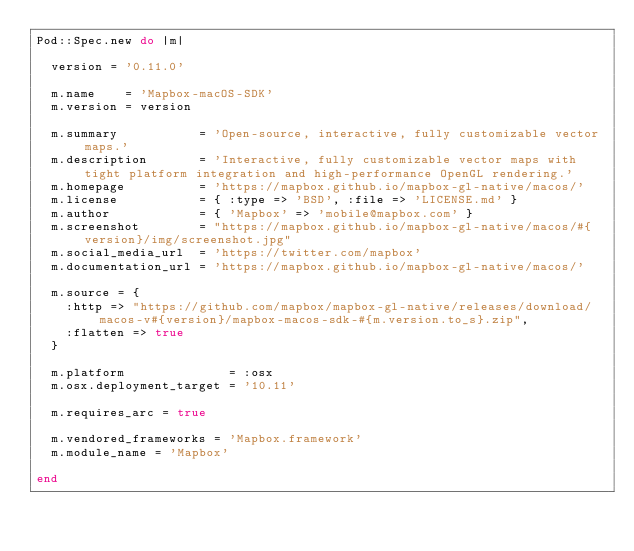<code> <loc_0><loc_0><loc_500><loc_500><_Ruby_>Pod::Spec.new do |m|

  version = '0.11.0'

  m.name    = 'Mapbox-macOS-SDK'
  m.version = version

  m.summary           = 'Open-source, interactive, fully customizable vector maps.'
  m.description       = 'Interactive, fully customizable vector maps with tight platform integration and high-performance OpenGL rendering.'
  m.homepage          = 'https://mapbox.github.io/mapbox-gl-native/macos/'
  m.license           = { :type => 'BSD', :file => 'LICENSE.md' }
  m.author            = { 'Mapbox' => 'mobile@mapbox.com' }
  m.screenshot        = "https://mapbox.github.io/mapbox-gl-native/macos/#{version}/img/screenshot.jpg"
  m.social_media_url  = 'https://twitter.com/mapbox'
  m.documentation_url = 'https://mapbox.github.io/mapbox-gl-native/macos/'

  m.source = {
    :http => "https://github.com/mapbox/mapbox-gl-native/releases/download/macos-v#{version}/mapbox-macos-sdk-#{m.version.to_s}.zip",
    :flatten => true
  }

  m.platform              = :osx
  m.osx.deployment_target = '10.11'

  m.requires_arc = true

  m.vendored_frameworks = 'Mapbox.framework'
  m.module_name = 'Mapbox'

end
</code> 